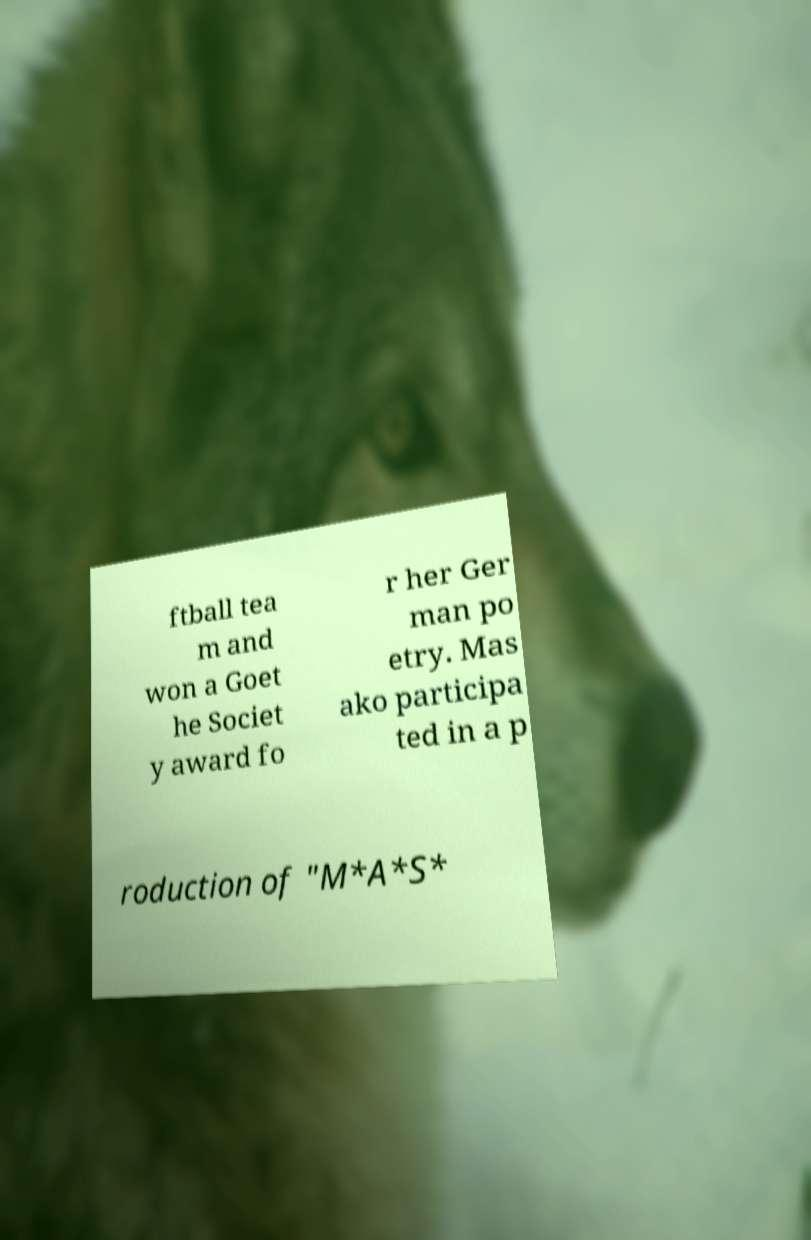Can you accurately transcribe the text from the provided image for me? ftball tea m and won a Goet he Societ y award fo r her Ger man po etry. Mas ako participa ted in a p roduction of "M*A*S* 